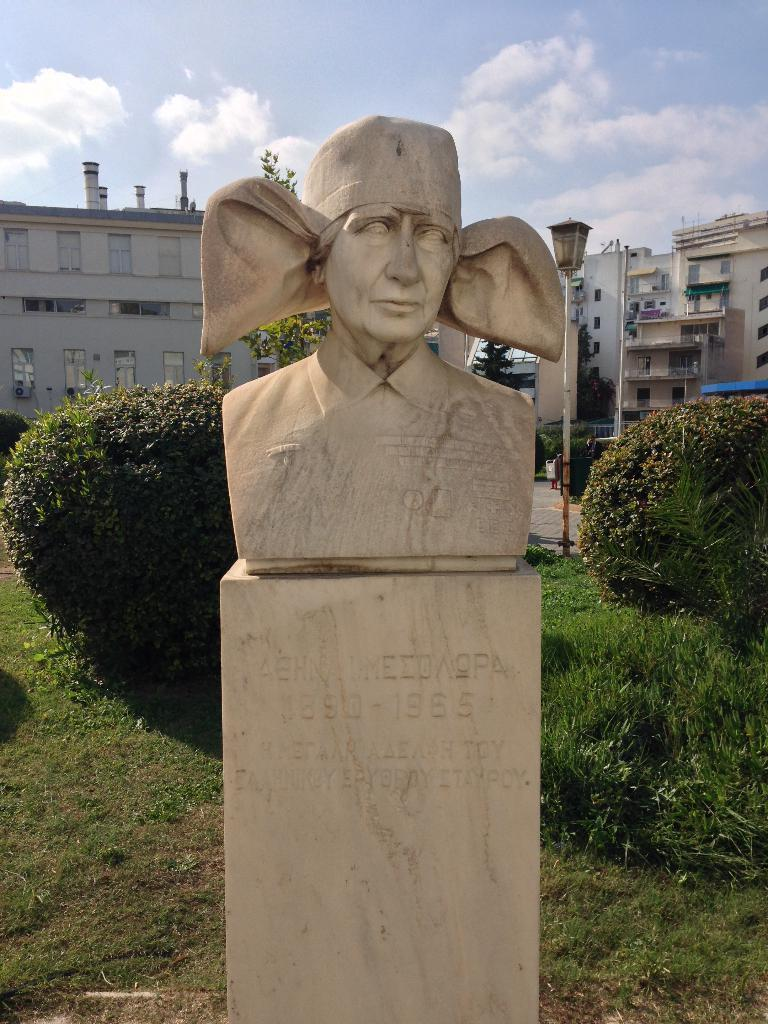What is the main subject in the image? There is a statue in the image. What other elements can be seen in the image besides the statue? There are trees, buildings with windows, and the sky visible in the background of the image. Can you describe the sky in the image? The sky is visible in the background of the image, and clouds are present in it. What type of corn can be seen growing near the statue in the image? There is no corn present in the image; it features a statue, trees, buildings, and a sky with clouds. 